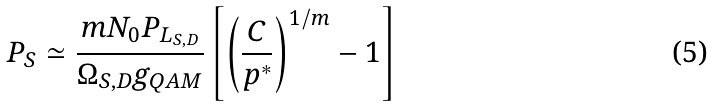<formula> <loc_0><loc_0><loc_500><loc_500>P _ { S } \simeq \frac { m N _ { 0 } P _ { L _ { S , D } } } { \Omega _ { S , D } g _ { Q A M } } \left [ \left ( \frac { C } { p ^ { * } } \right ) ^ { 1 / m } - 1 \right ]</formula> 